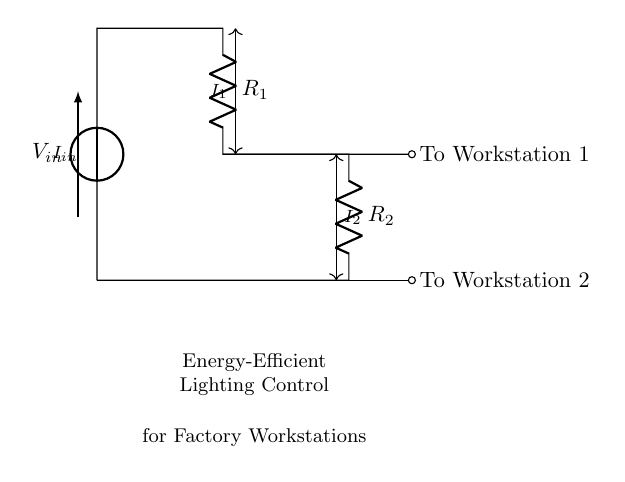What is the input voltage in this circuit? The input voltage, represented by V_in, is supplied to the circuit; however, the specific value is not provided in the diagram. It is a variable that affects both the current and voltage distribution in the circuit.
Answer: V_in What are the resistances in this current divider? The circuit contains two resistors: R_1 and R_2. These are specified in the diagram and are fundamental to determining how the current divides between the two branches.
Answer: R_1 and R_2 What is the relationship between the input current and the currents in the branches? The input current I_in is divided into two currents, I_1 and I_2, which flow through R_1 and R_2, respectively. According to the current divider rule, the currents in each branch are inversely proportional to the resistances.
Answer: I_in = I_1 + I_2 Which branch has the greater current? The branch with the smaller resistance has the greater current. Since R_1 and R_2 are the only resistors, a comparison of their values would indicate which one receives a greater portion of the input current.
Answer: Depends on R_1 and R_2 What does the output current I_2 signify in this context? The current I_2 represents the portion of the total input current that is supplied to Workstation 2. It is an essential measurement for assessing the power supplied to the lighting for that particular workstation.
Answer: Output to Workstation 2 How does this circuit contribute to energy-efficient lighting control in a factory? By utilizing a current divider, the circuit allows for the independent control of current to different workstations. This enables optimized lighting according to specific needs, leading to energy savings and efficiency in the factory environment.
Answer: Energy-efficient lighting control 